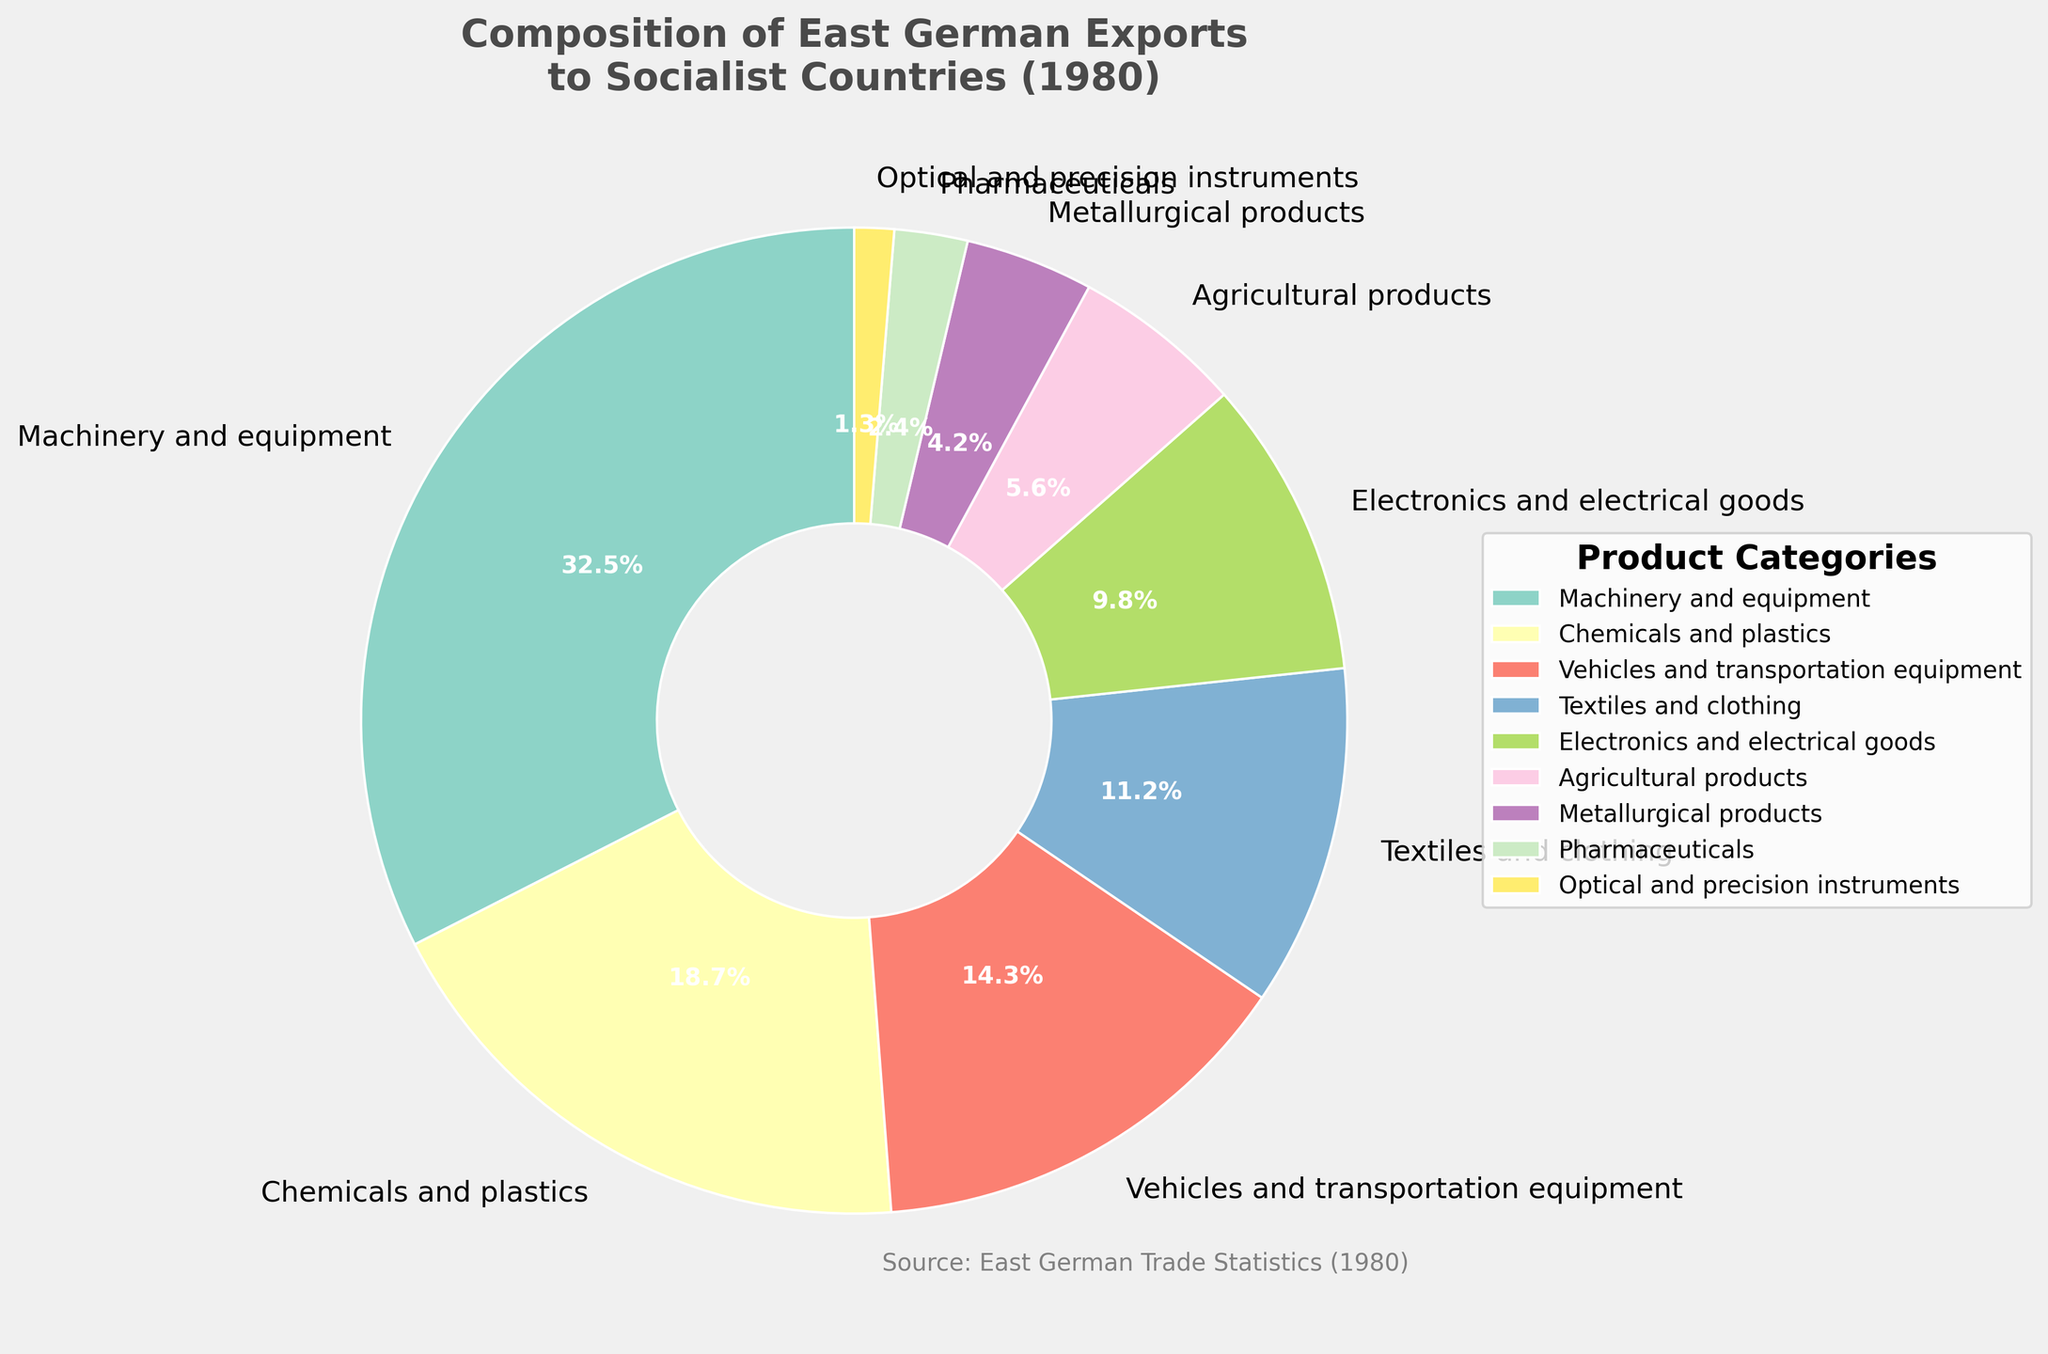What is the combined percentage of "Machinery and equipment" and "Vehicles and transportation equipment"? Add the percentages of "Machinery and equipment" (32.5%) and "Vehicles and transportation equipment" (14.3%). 32.5% + 14.3% = 46.8%
Answer: 46.8% Which export category has the highest percentage? Identify the category with the largest slice in the pie chart. "Machinery and equipment" has the highest percentage with 32.5%
Answer: Machinery and equipment Which export category has the smallest percentage? Identify the category with the smallest slice in the pie chart. "Optical and precision instruments" has the smallest percentage with 1.3%
Answer: Optical and precision instruments How much higher is the percentage of "Chemicals and plastics" compared to "Agricultural products"? Subtract the percentage of "Agricultural products" (5.6%) from "Chemicals and plastics" (18.7%). 18.7% - 5.6% = 13.1%
Answer: 13.1% How many categories have a percentage greater than 10%? Count the number of categories with a percentage higher than 10%: "Machinery and equipment", "Chemicals and plastics", "Vehicles and transportation equipment", and "Textiles and clothing". There are 4 such categories
Answer: 4 What is the difference in percentage between "Electronics and electrical goods" and "Pharmaceuticals"? Subtract the percentage of "Pharmaceuticals" (2.4%) from "Electronics and electrical goods" (9.8%). 9.8% - 2.4% = 7.4%
Answer: 7.4% Which category has a larger percentage, "Textiles and clothing" or "Metallurgical products"? Compare the percentages of "Textiles and clothing" (11.2%) and "Metallurgical products" (4.2%). The percentage of "Textiles and clothing" is larger
Answer: Textiles and clothing If the percentage of "Machinery and equipment" decreased by 10%, what would its new percentage be? Subtract 10% from "Machinery and equipment" (32.5%). 32.5% - 10% = 22.5%
Answer: 22.5% If we combine the "Chemicals and plastics" and "Pharmaceuticals" categories, what is their total percentage? Add the percentages of "Chemicals and plastics" (18.7%) and "Pharmaceuticals" (2.4%). 18.7% + 2.4% = 21.1%
Answer: 21.1% Is the sum of the percentages of "Machinery and equipment" and "Textiles and clothing" greater than 40%? Add the percentages of "Machinery and equipment" (32.5%) and "Textiles and clothing" (11.2%). 32.5% + 11.2% = 43.7%, which is greater than 40%
Answer: Yes 